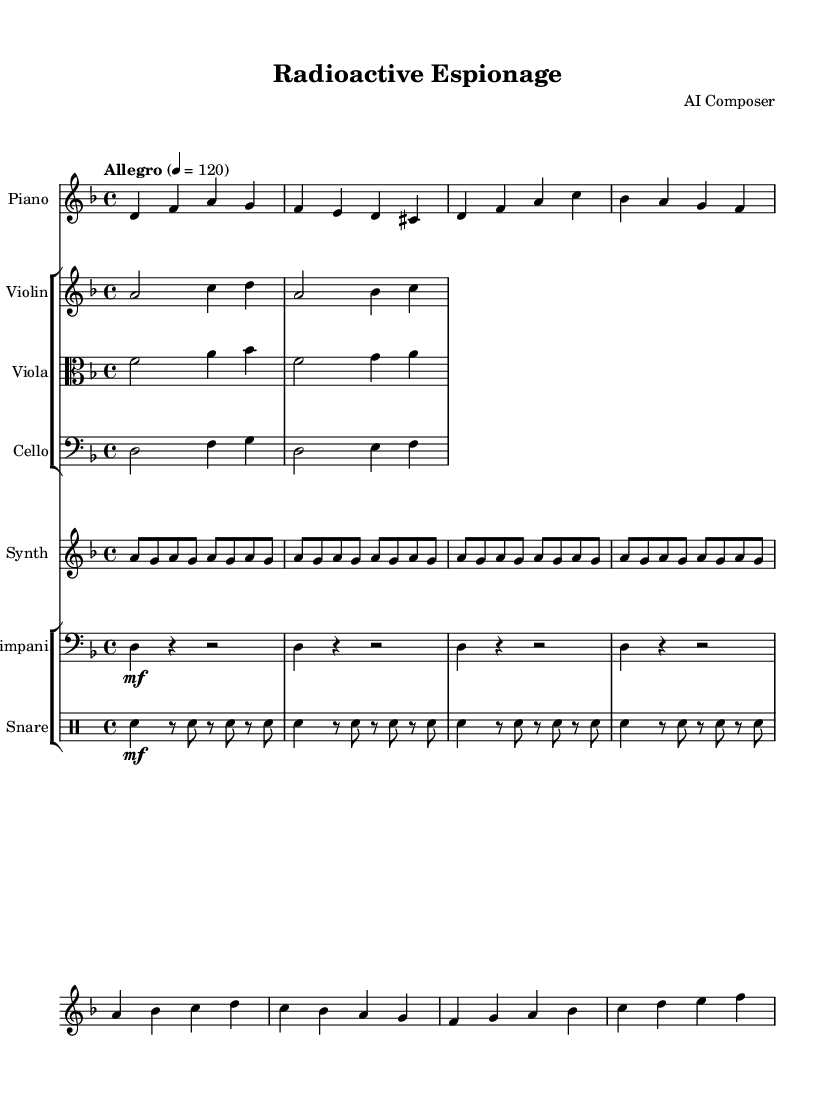What is the key signature of this music? The key signature is indicated at the beginning of the music, showing two flats. This places the piece in D minor.
Answer: D minor What is the time signature of this piece? The time signature is shown in the initial section of the score as 4/4, indicating four beats per measure and a quarter note gets one beat.
Answer: 4/4 What is the tempo marking given for this piece? The tempo marking, found in the score, shows "Allegro" with a metronome marking of 120, indicating a fast pace.
Answer: Allegro 120 How many instruments are featured in the score? By examining the score, there are four distinct instrumental parts: piano, strings (violin, viola, cello), and synth, as well as percussion (timpani and snare). Counting these gives a total of six distinct parts.
Answer: Six Which part has repeated notes in its section? The synth part, recognizable by its short rhythmic passages and repeated notes (a eight notes), clearly illustrates a pattern of repeated pitches.
Answer: Synth What dynamic marking appears in the violin part? In the violin part, the dynamic markings indicate that the section starts with a soft dynamic (piano) and then swells to a loud dynamic (forte). This provides a contrast within the phrase.
Answer: Piano to forte 